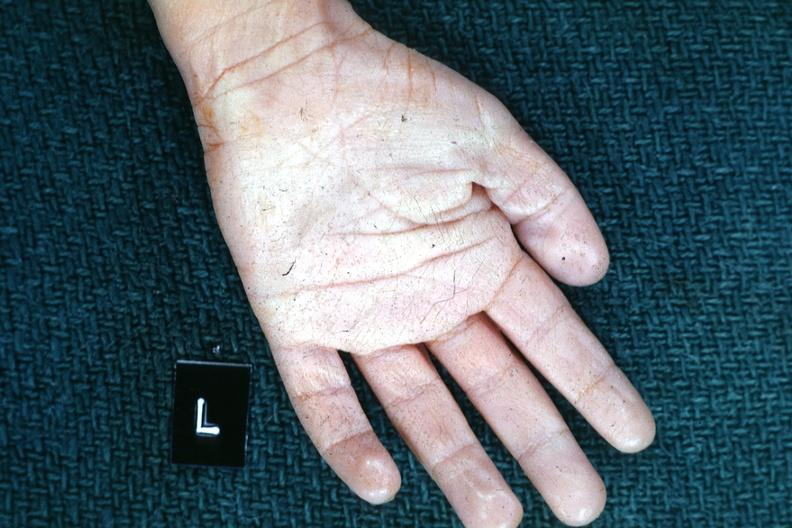what does this image show?
Answer the question using a single word or phrase. Left hand 